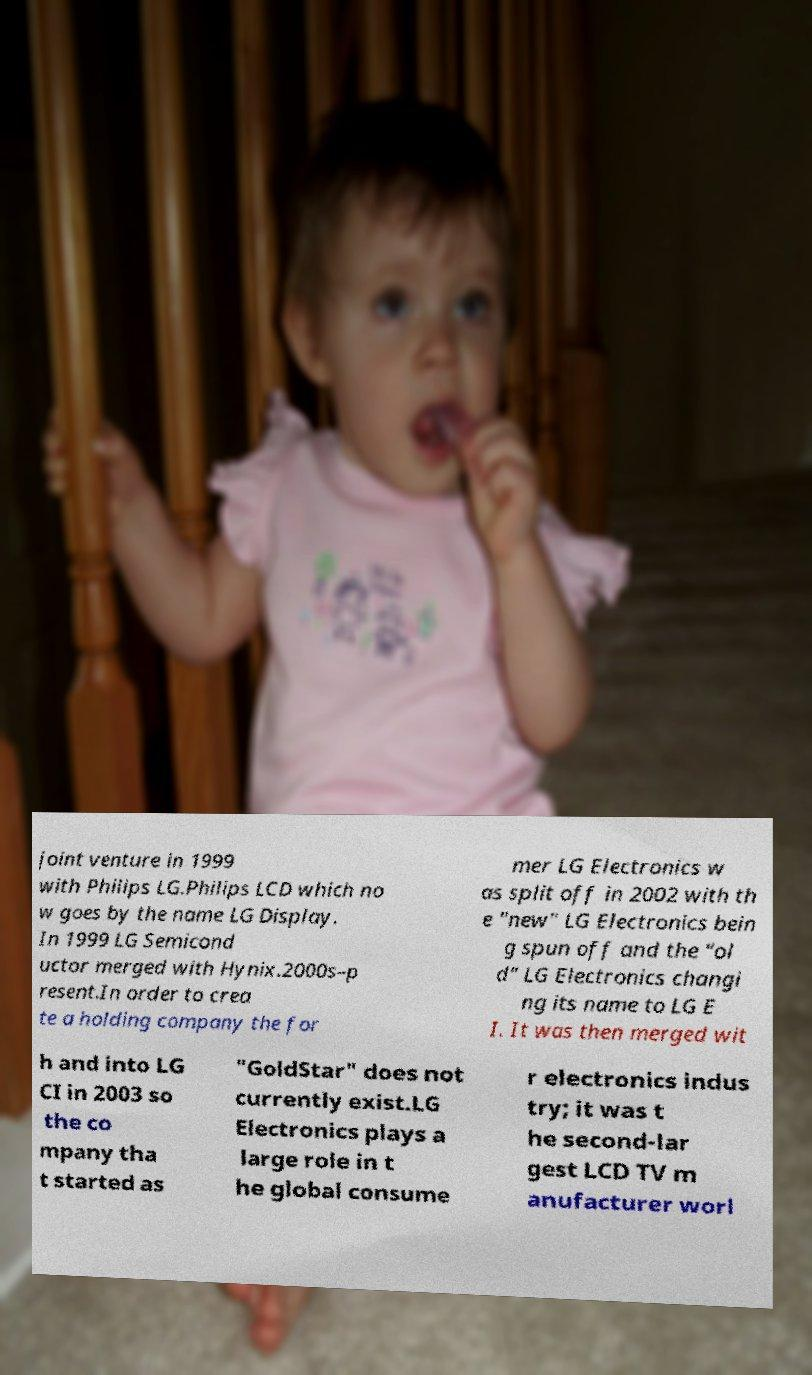I need the written content from this picture converted into text. Can you do that? joint venture in 1999 with Philips LG.Philips LCD which no w goes by the name LG Display. In 1999 LG Semicond uctor merged with Hynix.2000s–p resent.In order to crea te a holding company the for mer LG Electronics w as split off in 2002 with th e "new" LG Electronics bein g spun off and the "ol d" LG Electronics changi ng its name to LG E I. It was then merged wit h and into LG CI in 2003 so the co mpany tha t started as "GoldStar" does not currently exist.LG Electronics plays a large role in t he global consume r electronics indus try; it was t he second-lar gest LCD TV m anufacturer worl 